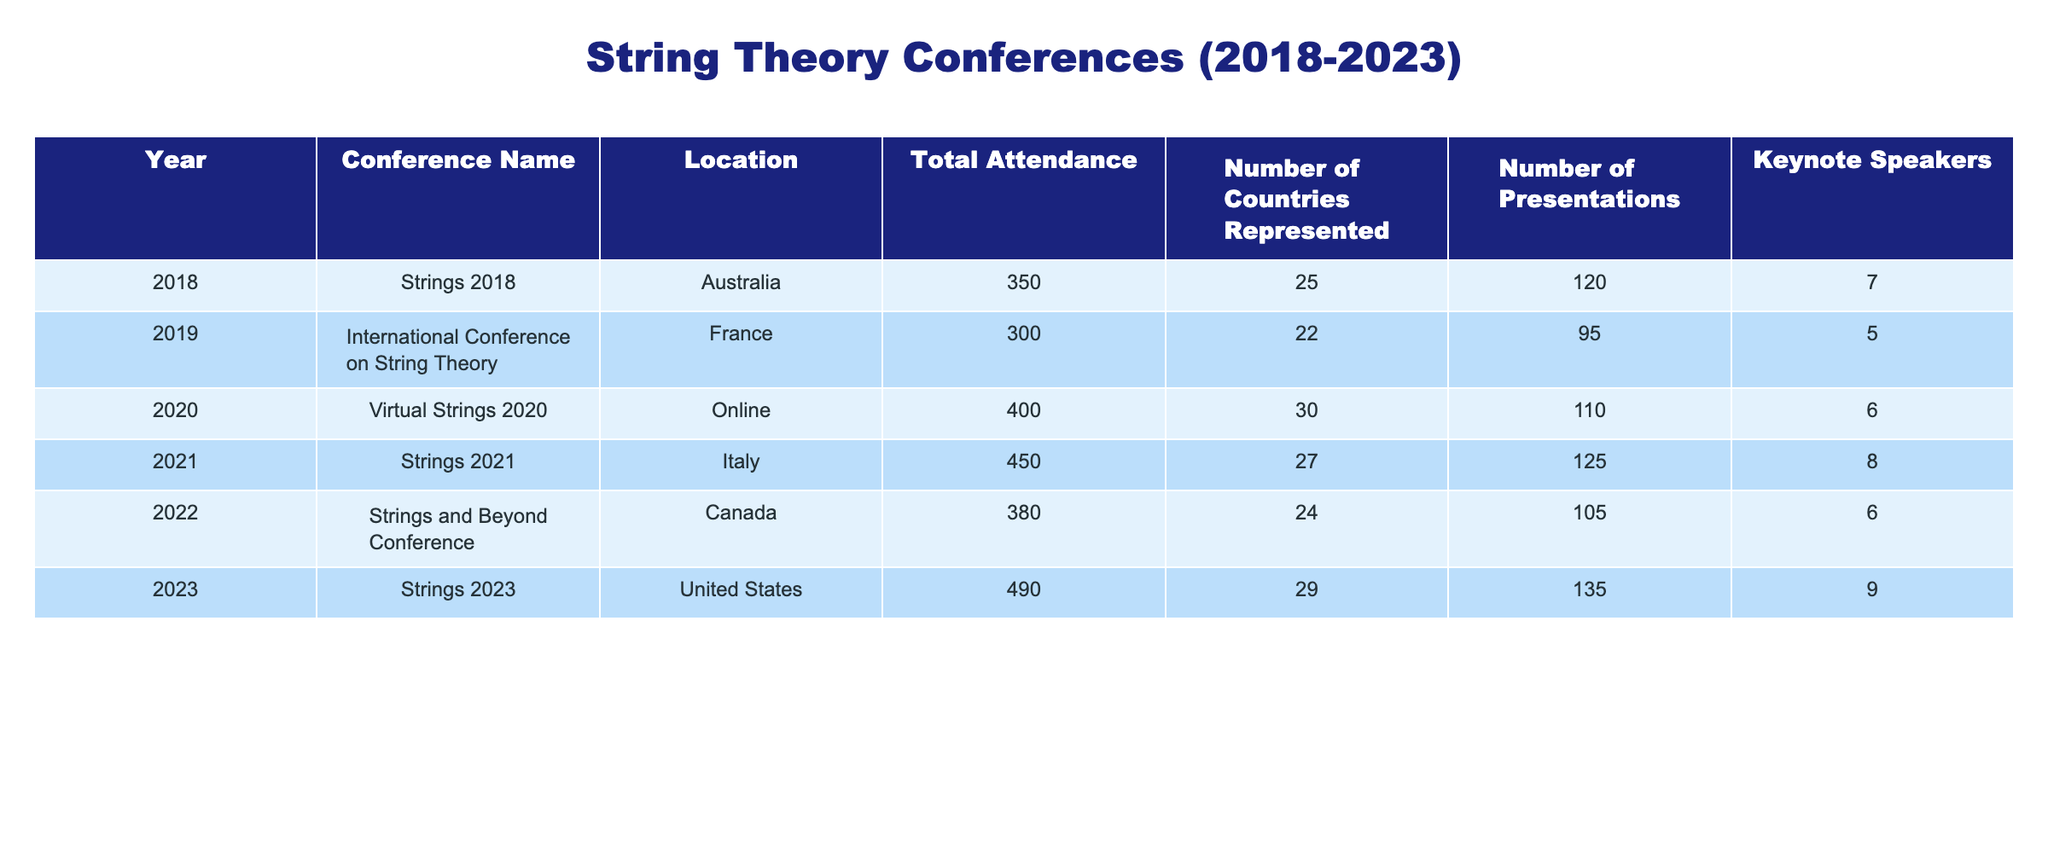What was the total attendance at Strings 2023? The table shows that the total attendance for the year 2023 is directly listed. I check the row for 2023 and find that the total attendance is 490.
Answer: 490 How many keynote speakers were there at the International Conference on String Theory in 2019? By locating the row for the 2019 conference in the table, I see the data for keynote speakers is provided. The number of keynote speakers for this conference is 5.
Answer: 5 Which conference had the highest attendance, and what was that number? To find the highest attendance, I compare all total attendance figures across the years. The highest number is 490, which corresponds to Strings 2023.
Answer: Strings 2023, 490 What is the average number of presentations from all the conferences listed? First, I gather the number of presentations: 120, 95, 110, 125, 105, and 135. Summing these gives 780. Since there are 6 conferences, I divide 780 by 6 to get the average: 130.
Answer: 130 Did the number of countries represented at Strings 2021 exceed that of Strings 2018? Checking the respective values for both conferences: Strings 2021 has 27 countries represented, while Strings 2018 has 25. Since 27 is greater than 25, the statement is true.
Answer: Yes How many more presentations were given at Strings 2023 compared to the International Conference on String Theory in 2019? From the table, Strings 2023 had 135 presentations and the 2019 conference had 95. To find the difference, I subtract: 135 - 95 = 40.
Answer: 40 Which year saw a decrease in total attendance compared to the previous year? I examine the total attendance for each year: 350 (2018), 300 (2019), 400 (2020), 450 (2021), 380 (2022), 490 (2023). The only decrease occurs from 2019 to 2020, where attendance fell from 300 to 400.
Answer: 2019 Was the number of keynote speakers at Strings 2021 higher or lower than at Strings and Beyond Conference in 2022? I compare the two years: Strings 2021 had 8 keynote speakers and Strings and Beyond Conference in 2022 had 6. Since 8 is higher than 6, I conclude it was higher.
Answer: Higher What is the total combined attendance of all conferences held in Canada? The table lists only one conference in Canada: Strings and Beyond Conference in 2022 with an attendance of 380. Since this is the only conference in Canada, the total is simply 380.
Answer: 380 